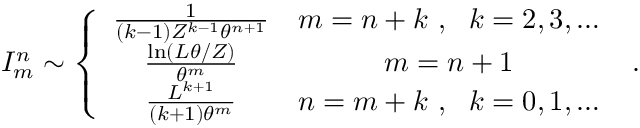Convert formula to latex. <formula><loc_0><loc_0><loc_500><loc_500>I _ { m } ^ { n } \sim \left \{ \begin{array} { c c } { \frac { 1 } { ( k - 1 ) Z ^ { k - 1 } \theta ^ { n + 1 } } } & { m = n + k \ , \ \ k = 2 , 3 , \dots } \\ { \frac { \ln ( L \theta / Z ) } { \theta ^ { m } } } & { m = n + 1 } \\ { \frac { L ^ { k + 1 } } { ( k + 1 ) \theta ^ { m } } } & { n = m + k \ , \ \ k = 0 , 1 , \dots } \end{array} \ .</formula> 